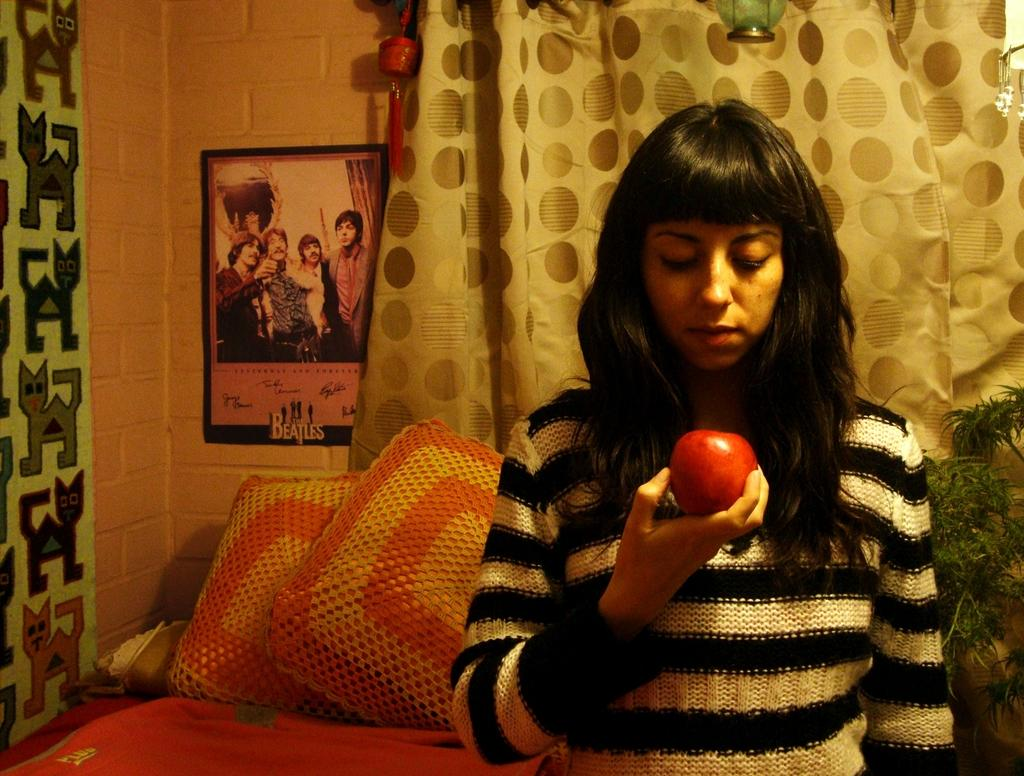Who is present in the image? There is a woman in the image. What is the woman holding in the image? The woman is holding a fruit. What can be seen in the background of the image? There are pillows, plants, a curtain, a wall, a poster, and some objects in the background of the image. What type of chin can be seen on the woman's grandfather in the image? There is no grandfather present in the image, and therefore no chin to describe. 